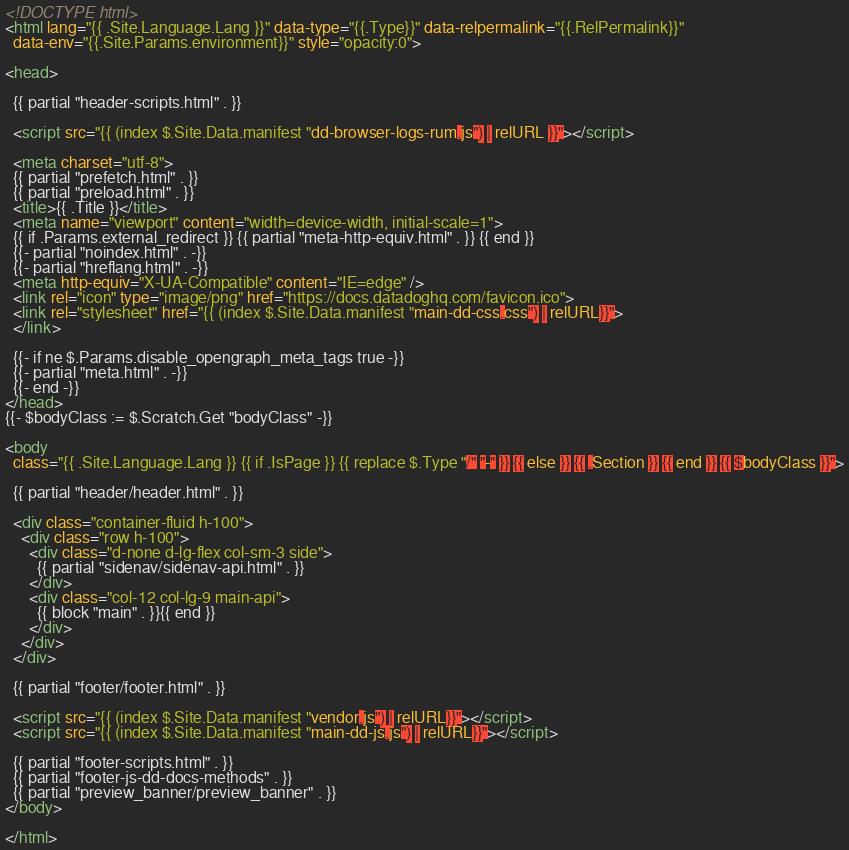Convert code to text. <code><loc_0><loc_0><loc_500><loc_500><_HTML_><!DOCTYPE html>
<html lang="{{ .Site.Language.Lang }}" data-type="{{.Type}}" data-relpermalink="{{.RelPermalink}}"
  data-env="{{.Site.Params.environment}}" style="opacity:0">

<head>

  {{ partial "header-scripts.html" . }}

  <script src="{{ (index $.Site.Data.manifest "dd-browser-logs-rum.js") | relURL }}"></script>

  <meta charset="utf-8">
  {{ partial "prefetch.html" . }}
  {{ partial "preload.html" . }}
  <title>{{ .Title }}</title>
  <meta name="viewport" content="width=device-width, initial-scale=1">
  {{ if .Params.external_redirect }} {{ partial "meta-http-equiv.html" . }} {{ end }}
  {{- partial "noindex.html" . -}}
  {{- partial "hreflang.html" . -}}
  <meta http-equiv="X-UA-Compatible" content="IE=edge" />
  <link rel="icon" type="image/png" href="https://docs.datadoghq.com/favicon.ico">
  <link rel="stylesheet" href="{{ (index $.Site.Data.manifest "main-dd-css.css") | relURL}}">
  </link>

  {{- if ne $.Params.disable_opengraph_meta_tags true -}}
  {{- partial "meta.html" . -}}
  {{- end -}}
</head>
{{- $bodyClass := $.Scratch.Get "bodyClass" -}}

<body
  class="{{ .Site.Language.Lang }} {{ if .IsPage }} {{ replace $.Type "/" "-" }} {{ else }} {{ .Section }} {{ end }} {{ $bodyClass }}">

  {{ partial "header/header.html" . }}

  <div class="container-fluid h-100">
    <div class="row h-100">
      <div class="d-none d-lg-flex col-sm-3 side">
        {{ partial "sidenav/sidenav-api.html" . }}
      </div>
      <div class="col-12 col-lg-9 main-api">
        {{ block "main" . }}{{ end }}
      </div>
    </div>
  </div>

  {{ partial "footer/footer.html" . }}

  <script src="{{ (index $.Site.Data.manifest "vendor.js") | relURL}}"></script>
  <script src="{{ (index $.Site.Data.manifest "main-dd-js.js") | relURL}}"></script>

  {{ partial "footer-scripts.html" . }}
  {{ partial "footer-js-dd-docs-methods" . }}
  {{ partial "preview_banner/preview_banner" . }}
</body>

</html>
</code> 